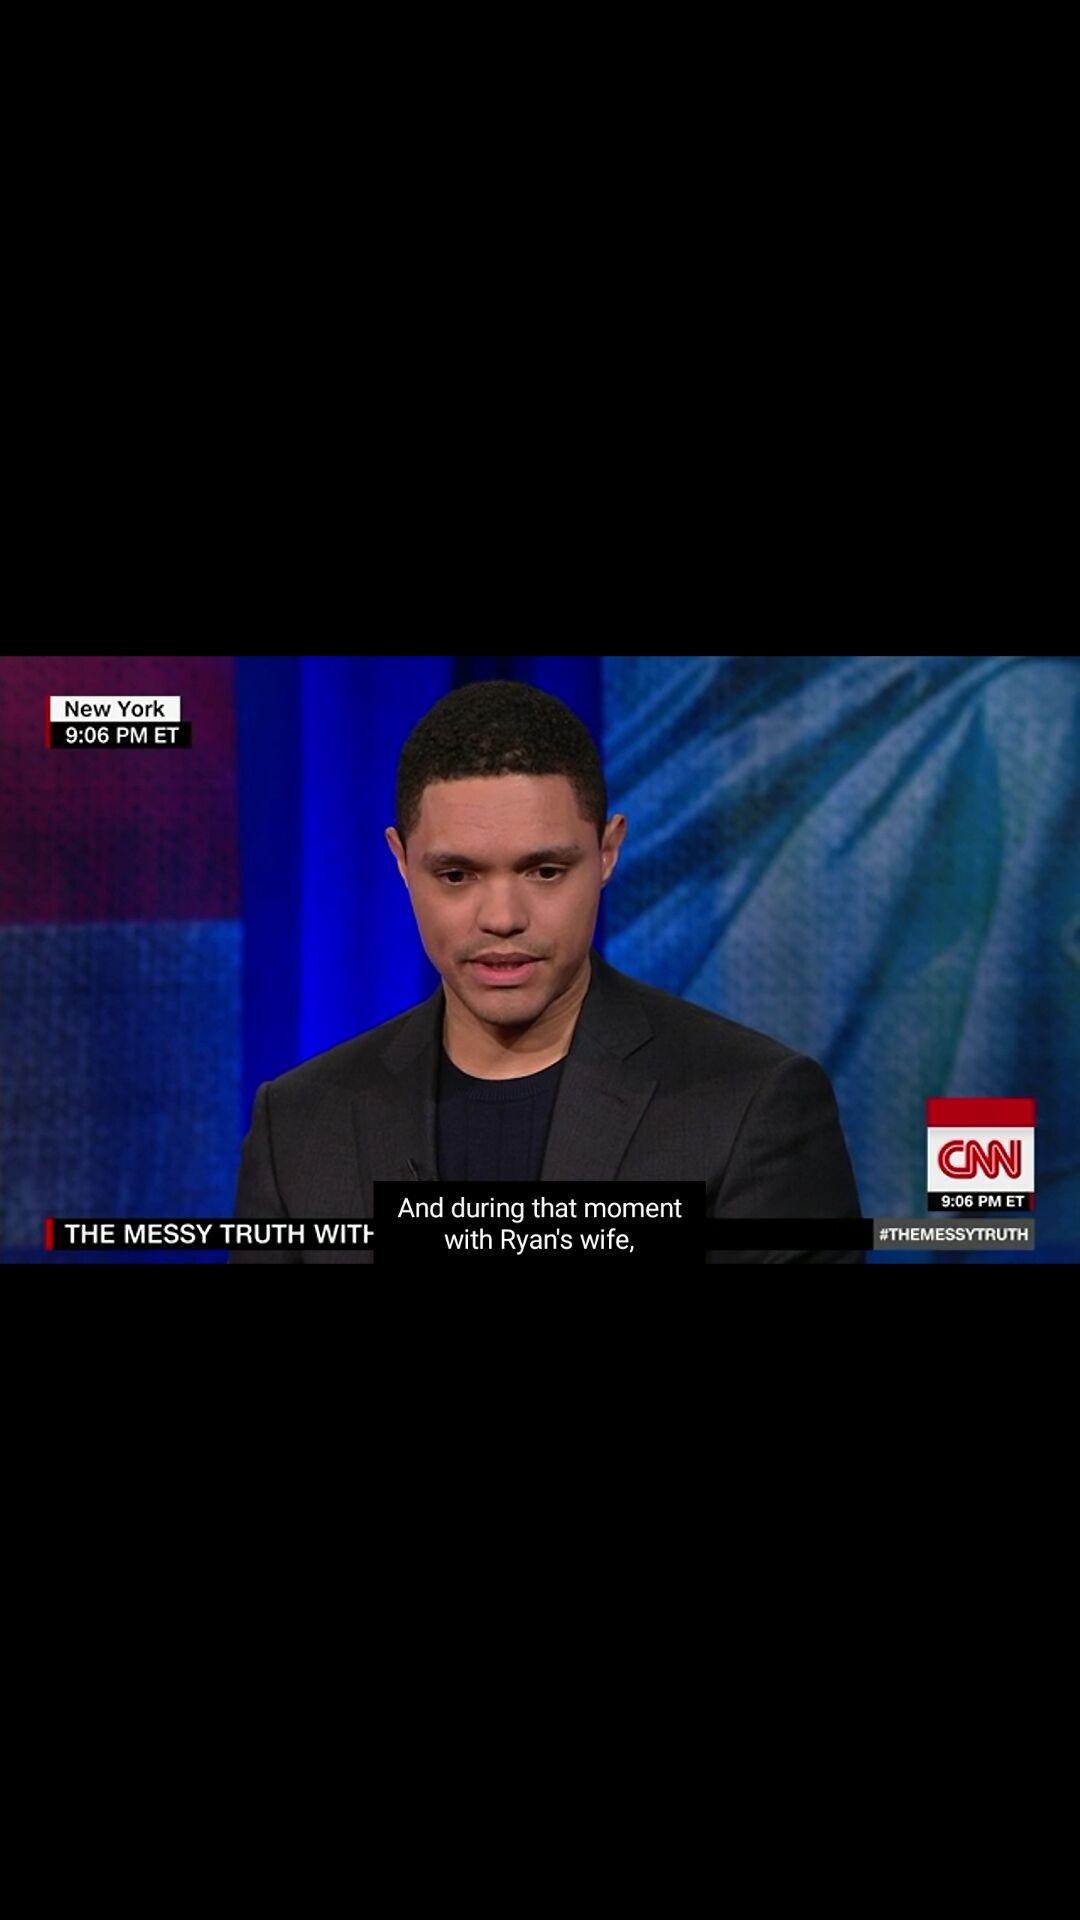What is the duration of the video? The duration of the video is 1 minute 6 seconds. 